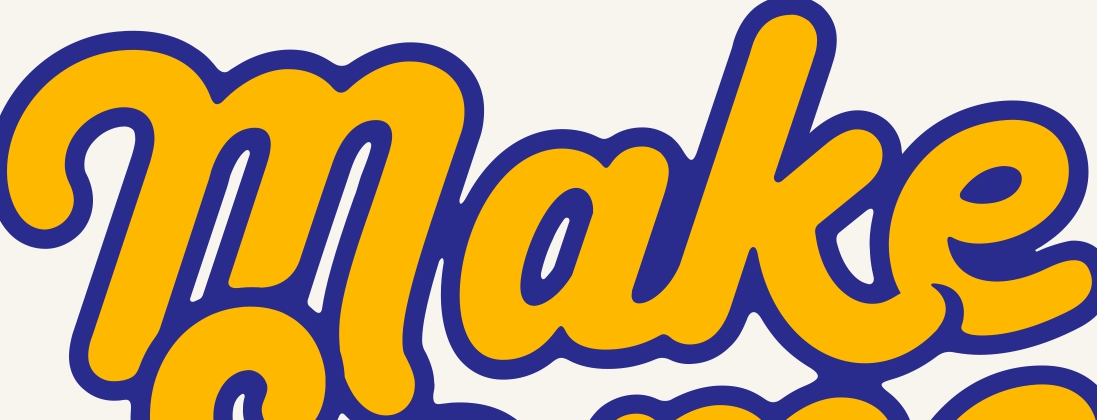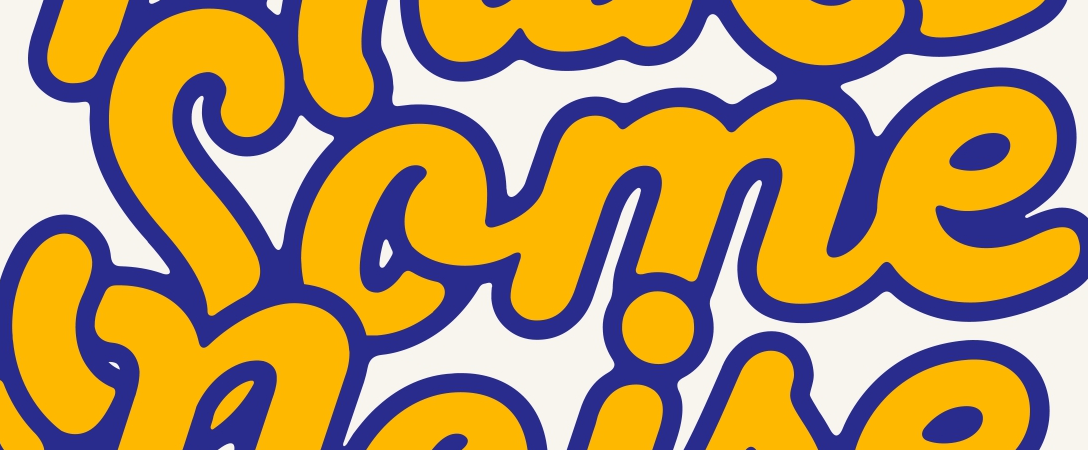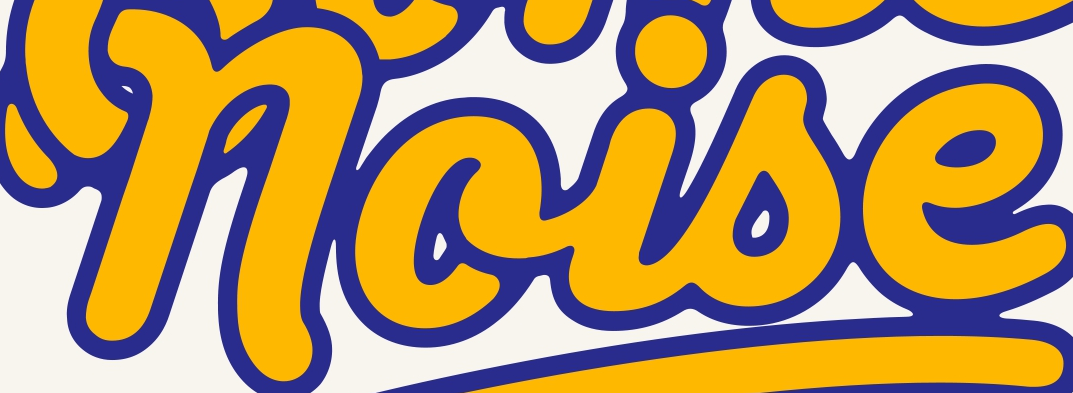What words are shown in these images in order, separated by a semicolon? make; Some; noise 